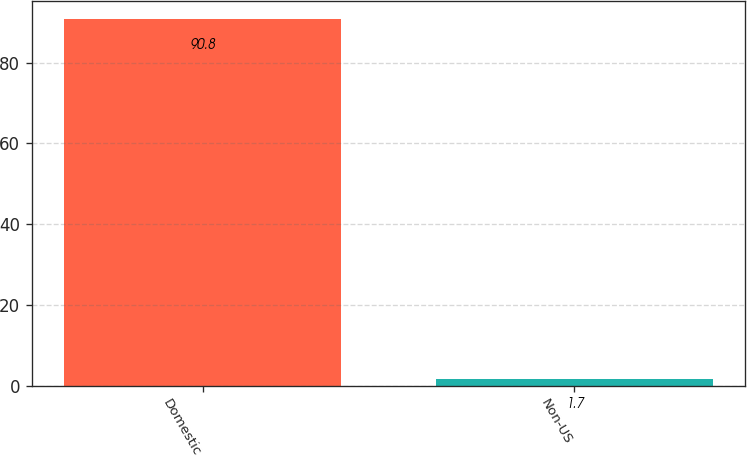<chart> <loc_0><loc_0><loc_500><loc_500><bar_chart><fcel>Domestic<fcel>Non-US<nl><fcel>90.8<fcel>1.7<nl></chart> 